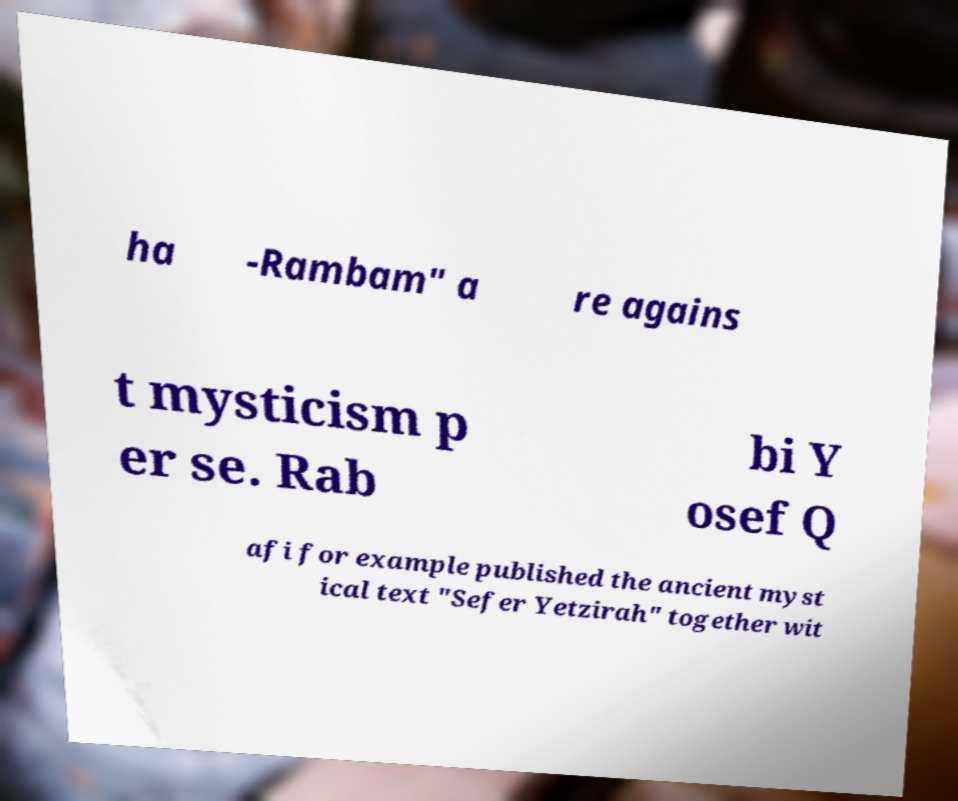Could you assist in decoding the text presented in this image and type it out clearly? ha -Rambam" a re agains t mysticism p er se. Rab bi Y osef Q afi for example published the ancient myst ical text "Sefer Yetzirah" together wit 